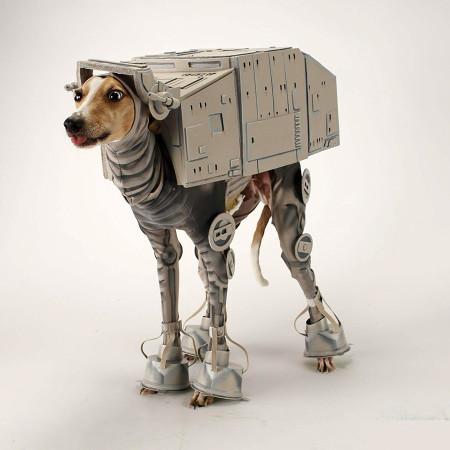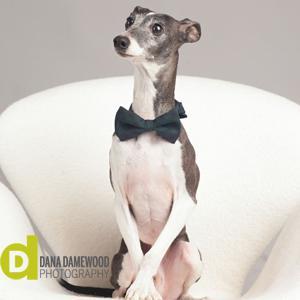The first image is the image on the left, the second image is the image on the right. For the images displayed, is the sentence "There are more dogs in the right image than in the left." factually correct? Answer yes or no. No. 